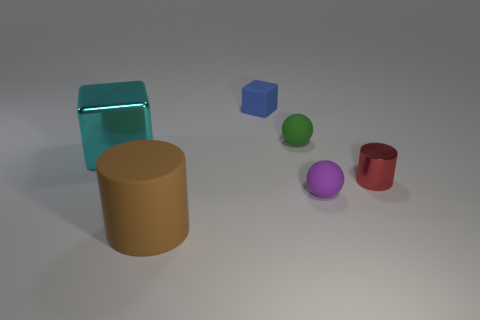There is a blue rubber object; is it the same size as the matte ball behind the tiny metal cylinder? The blue rubber object appears to be a bit larger in comparison to the matte ball located behind the small metal cylinder. Both objects are spherical in shape, yet the subtle differences in size are visible upon closer examination. 